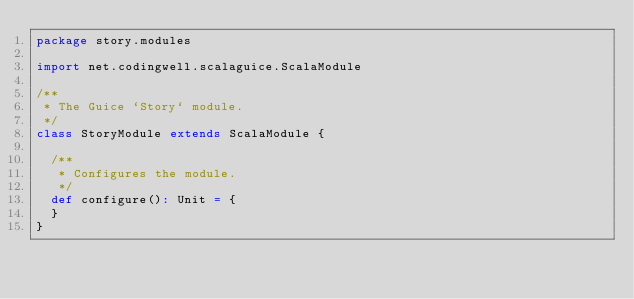Convert code to text. <code><loc_0><loc_0><loc_500><loc_500><_Scala_>package story.modules

import net.codingwell.scalaguice.ScalaModule

/**
 * The Guice `Story` module.
 */
class StoryModule extends ScalaModule {

  /**
   * Configures the module.
   */
  def configure(): Unit = {
  }
}
</code> 